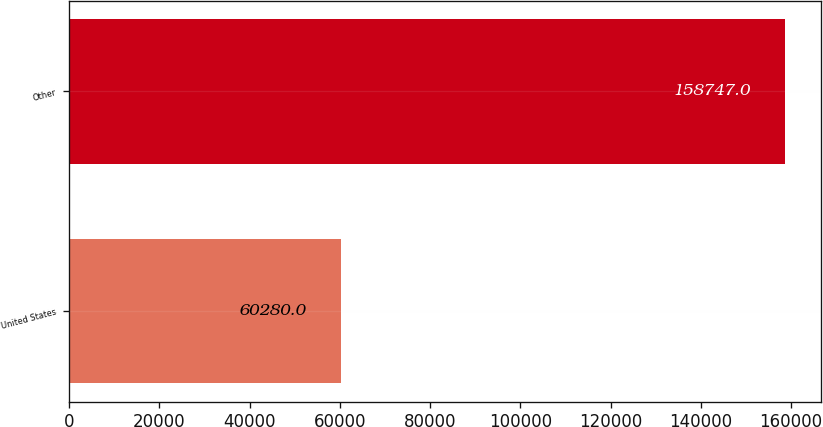<chart> <loc_0><loc_0><loc_500><loc_500><bar_chart><fcel>United States<fcel>Other<nl><fcel>60280<fcel>158747<nl></chart> 